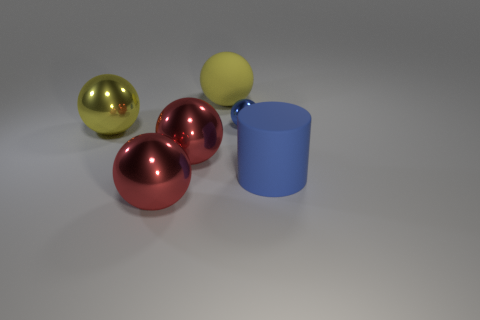Subtract all blue balls. How many balls are left? 4 Subtract all rubber spheres. How many spheres are left? 4 Subtract all brown spheres. Subtract all red cylinders. How many spheres are left? 5 Add 4 large blue metal blocks. How many objects exist? 10 Subtract all balls. How many objects are left? 1 Subtract 0 cyan cylinders. How many objects are left? 6 Subtract all blue things. Subtract all yellow rubber spheres. How many objects are left? 3 Add 1 small blue metal balls. How many small blue metal balls are left? 2 Add 2 blue metallic spheres. How many blue metallic spheres exist? 3 